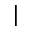<formula> <loc_0><loc_0><loc_500><loc_500>|</formula> 